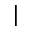<formula> <loc_0><loc_0><loc_500><loc_500>|</formula> 